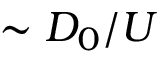Convert formula to latex. <formula><loc_0><loc_0><loc_500><loc_500>\sim D _ { 0 } / U</formula> 